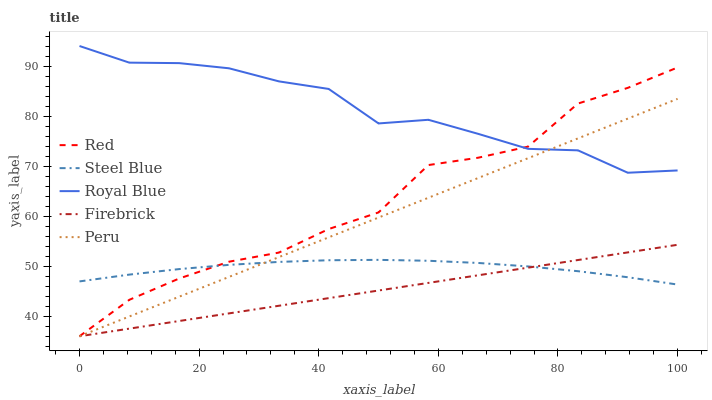Does Firebrick have the minimum area under the curve?
Answer yes or no. Yes. Does Royal Blue have the maximum area under the curve?
Answer yes or no. Yes. Does Royal Blue have the minimum area under the curve?
Answer yes or no. No. Does Firebrick have the maximum area under the curve?
Answer yes or no. No. Is Firebrick the smoothest?
Answer yes or no. Yes. Is Red the roughest?
Answer yes or no. Yes. Is Royal Blue the smoothest?
Answer yes or no. No. Is Royal Blue the roughest?
Answer yes or no. No. Does Peru have the lowest value?
Answer yes or no. Yes. Does Royal Blue have the lowest value?
Answer yes or no. No. Does Royal Blue have the highest value?
Answer yes or no. Yes. Does Firebrick have the highest value?
Answer yes or no. No. Is Steel Blue less than Royal Blue?
Answer yes or no. Yes. Is Royal Blue greater than Firebrick?
Answer yes or no. Yes. Does Red intersect Steel Blue?
Answer yes or no. Yes. Is Red less than Steel Blue?
Answer yes or no. No. Is Red greater than Steel Blue?
Answer yes or no. No. Does Steel Blue intersect Royal Blue?
Answer yes or no. No. 